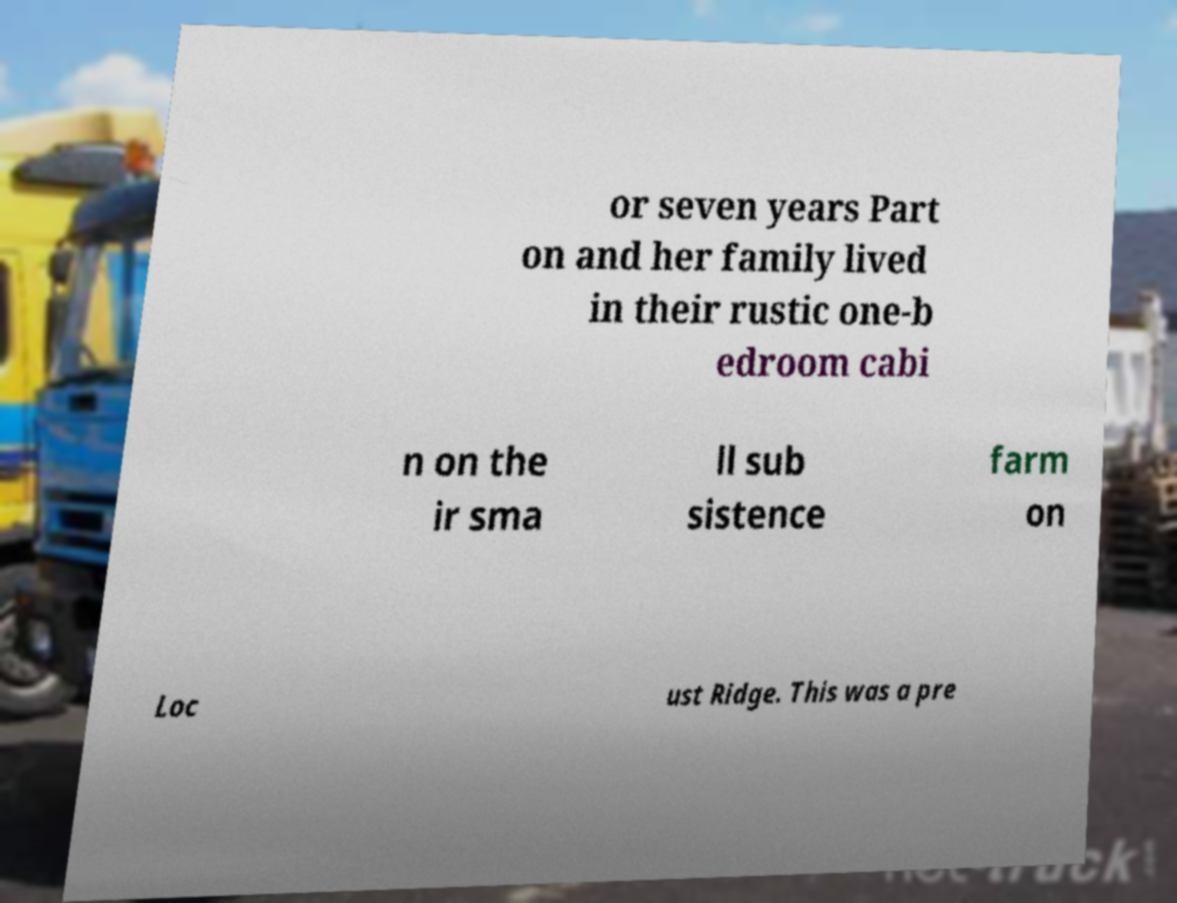Could you assist in decoding the text presented in this image and type it out clearly? or seven years Part on and her family lived in their rustic one-b edroom cabi n on the ir sma ll sub sistence farm on Loc ust Ridge. This was a pre 